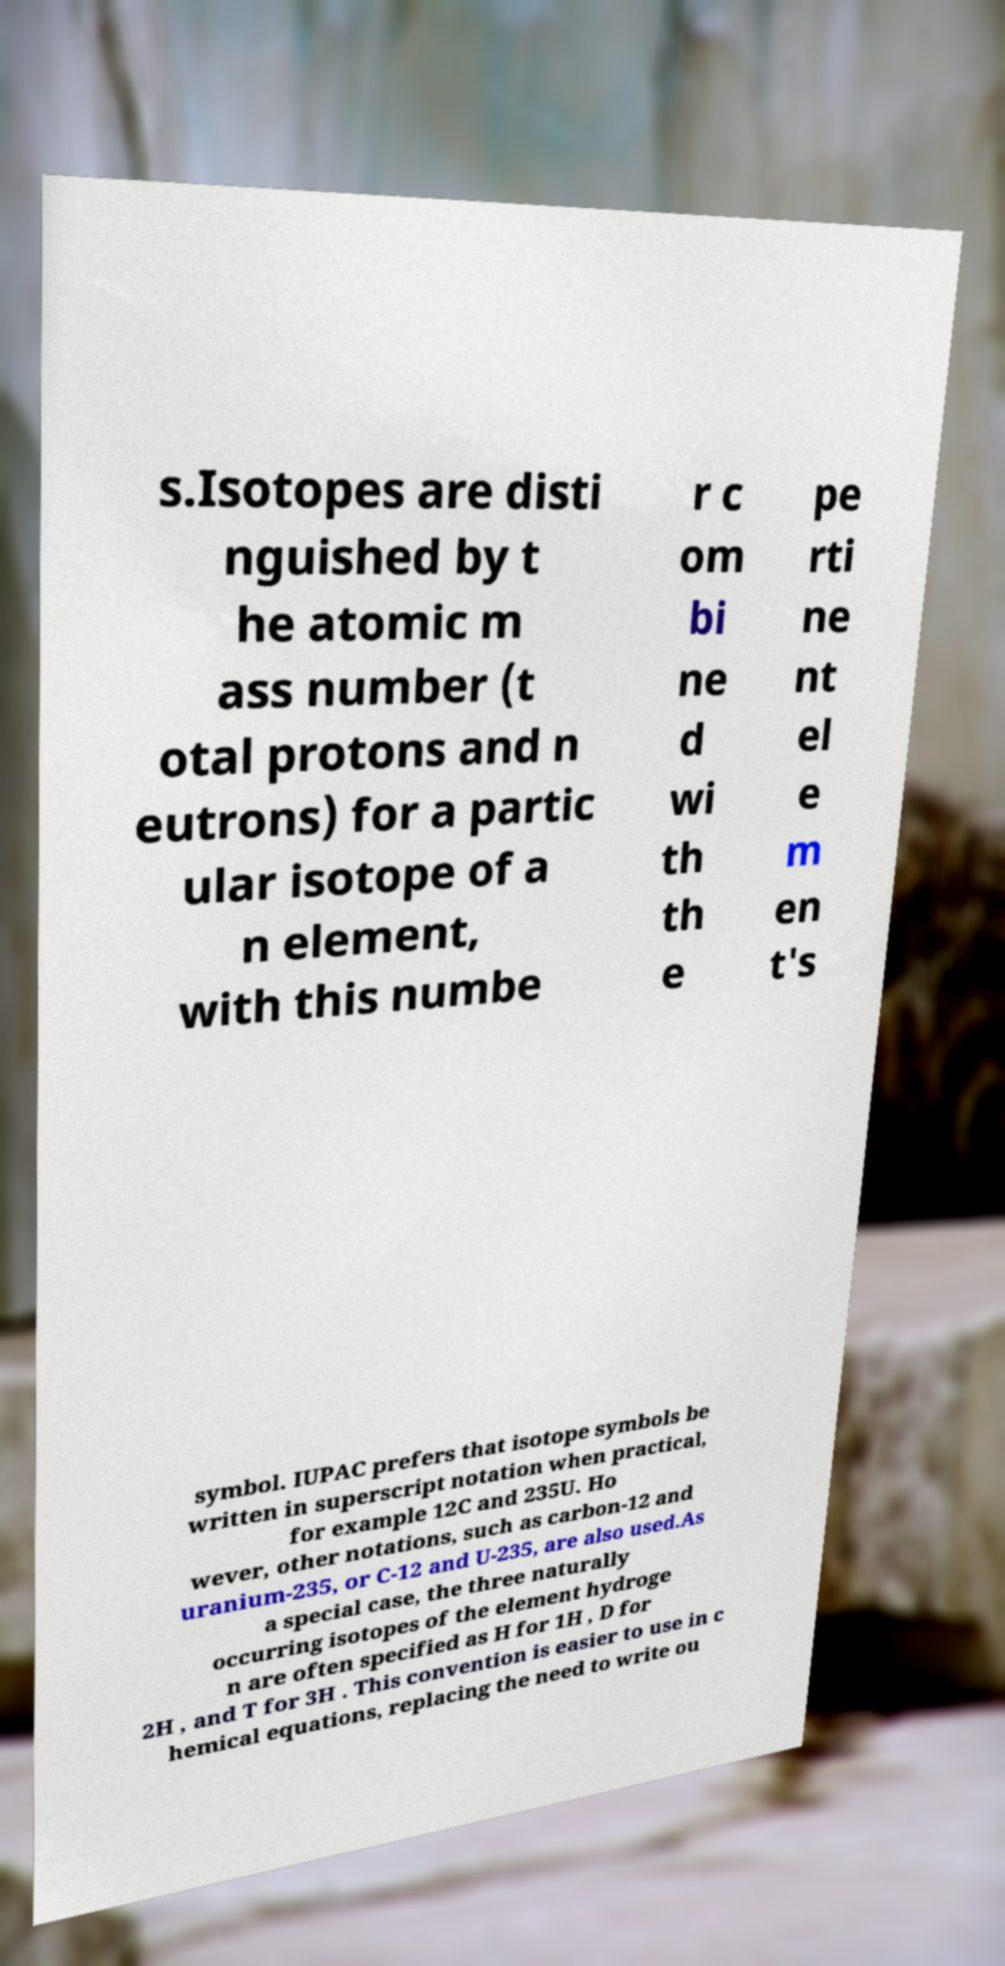Could you extract and type out the text from this image? s.Isotopes are disti nguished by t he atomic m ass number (t otal protons and n eutrons) for a partic ular isotope of a n element, with this numbe r c om bi ne d wi th th e pe rti ne nt el e m en t's symbol. IUPAC prefers that isotope symbols be written in superscript notation when practical, for example 12C and 235U. Ho wever, other notations, such as carbon-12 and uranium-235, or C-12 and U-235, are also used.As a special case, the three naturally occurring isotopes of the element hydroge n are often specified as H for 1H , D for 2H , and T for 3H . This convention is easier to use in c hemical equations, replacing the need to write ou 